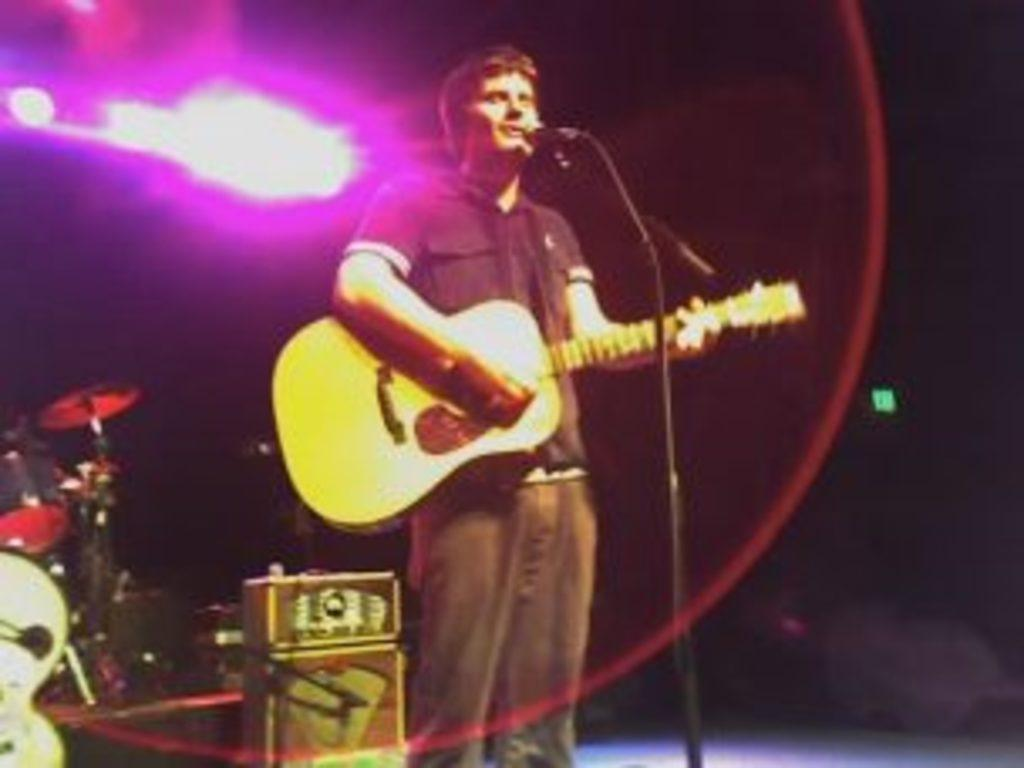Who is the main subject in the image? There is a man in the image. What is the man doing in the image? The man is singing a song. What instrument is the man holding in the image? The man is holding a guitar. What other musical instrument can be seen in the image? There are drums on the left side of the image. Where can we find a tree providing shade in the image? There is no tree or shade present in the image. How many books are visible on the drums in the image? There are no books visible on the drums in the image. 